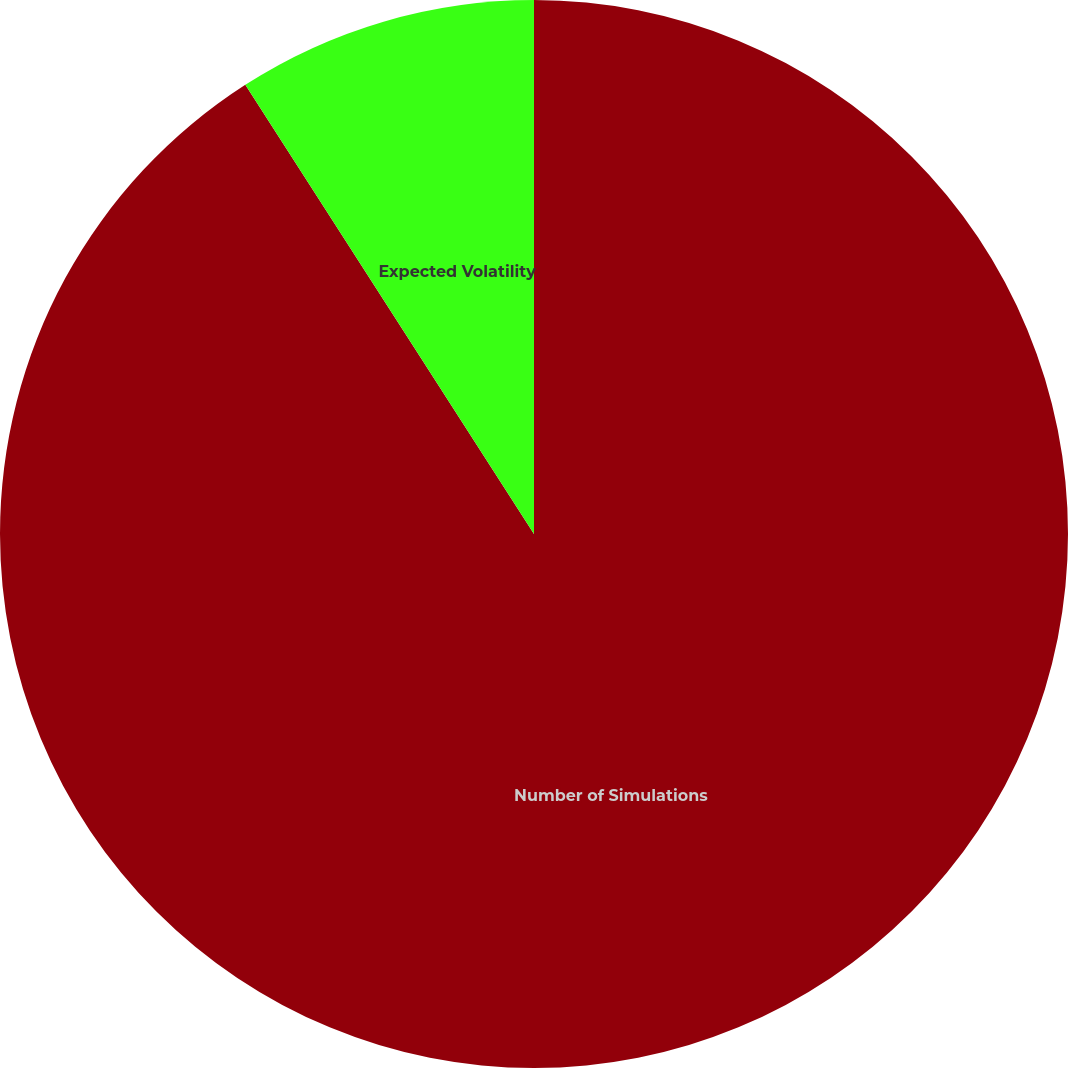Convert chart to OTSL. <chart><loc_0><loc_0><loc_500><loc_500><pie_chart><fcel>Number of Simulations<fcel>Expected Volatility<fcel>Risk-Free Rate<nl><fcel>90.91%<fcel>9.09%<fcel>0.0%<nl></chart> 